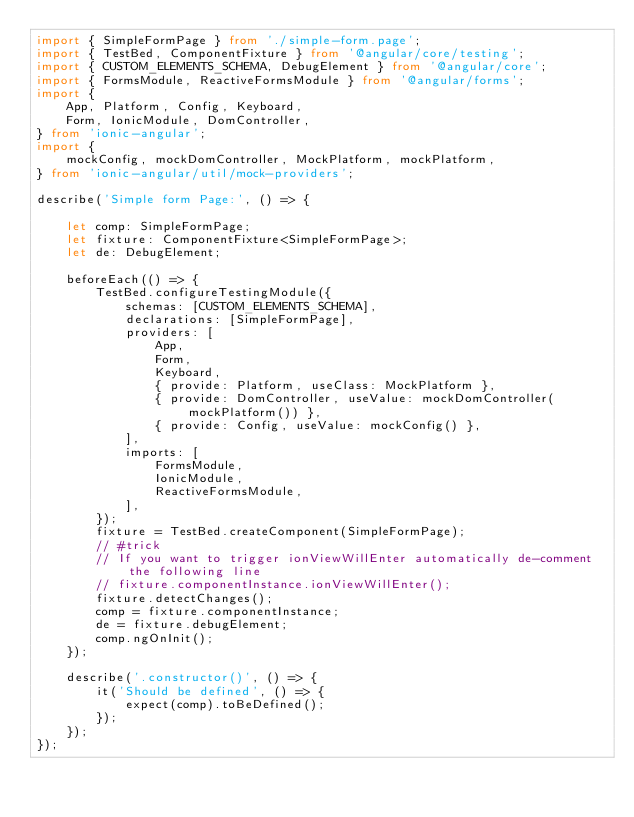Convert code to text. <code><loc_0><loc_0><loc_500><loc_500><_TypeScript_>import { SimpleFormPage } from './simple-form.page';
import { TestBed, ComponentFixture } from '@angular/core/testing';
import { CUSTOM_ELEMENTS_SCHEMA, DebugElement } from '@angular/core';
import { FormsModule, ReactiveFormsModule } from '@angular/forms';
import {
    App, Platform, Config, Keyboard,
    Form, IonicModule, DomController,
} from 'ionic-angular';
import {
    mockConfig, mockDomController, MockPlatform, mockPlatform,
} from 'ionic-angular/util/mock-providers';

describe('Simple form Page:', () => {

    let comp: SimpleFormPage;
    let fixture: ComponentFixture<SimpleFormPage>;
    let de: DebugElement;

    beforeEach(() => {
        TestBed.configureTestingModule({
            schemas: [CUSTOM_ELEMENTS_SCHEMA],
            declarations: [SimpleFormPage],
            providers: [
                App,
                Form,
                Keyboard,
                { provide: Platform, useClass: MockPlatform },
                { provide: DomController, useValue: mockDomController(mockPlatform()) },
                { provide: Config, useValue: mockConfig() },
            ],
            imports: [
                FormsModule,
                IonicModule,
                ReactiveFormsModule,
            ],
        });
        fixture = TestBed.createComponent(SimpleFormPage);
        // #trick
        // If you want to trigger ionViewWillEnter automatically de-comment the following line
        // fixture.componentInstance.ionViewWillEnter();
        fixture.detectChanges();
        comp = fixture.componentInstance;
        de = fixture.debugElement;
        comp.ngOnInit();
    });

    describe('.constructor()', () => {
        it('Should be defined', () => {
            expect(comp).toBeDefined();
        });
    });
});
</code> 